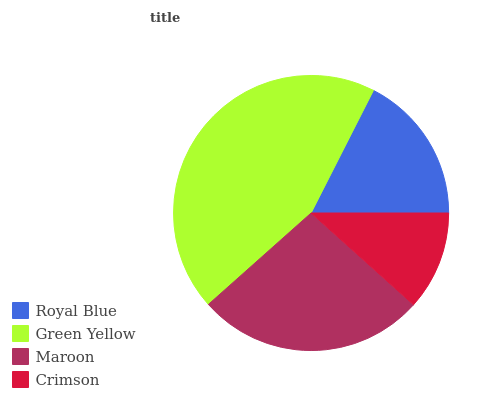Is Crimson the minimum?
Answer yes or no. Yes. Is Green Yellow the maximum?
Answer yes or no. Yes. Is Maroon the minimum?
Answer yes or no. No. Is Maroon the maximum?
Answer yes or no. No. Is Green Yellow greater than Maroon?
Answer yes or no. Yes. Is Maroon less than Green Yellow?
Answer yes or no. Yes. Is Maroon greater than Green Yellow?
Answer yes or no. No. Is Green Yellow less than Maroon?
Answer yes or no. No. Is Maroon the high median?
Answer yes or no. Yes. Is Royal Blue the low median?
Answer yes or no. Yes. Is Green Yellow the high median?
Answer yes or no. No. Is Green Yellow the low median?
Answer yes or no. No. 